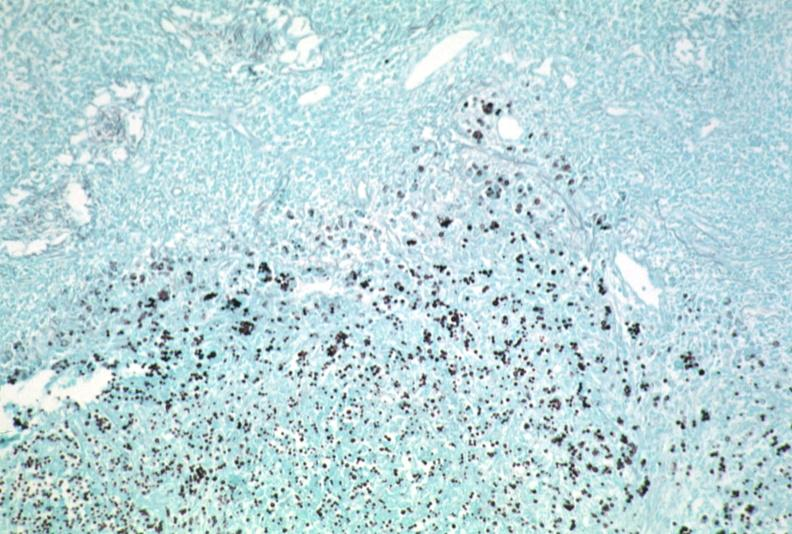does this image show lymph node, cryptococcosis gms?
Answer the question using a single word or phrase. Yes 